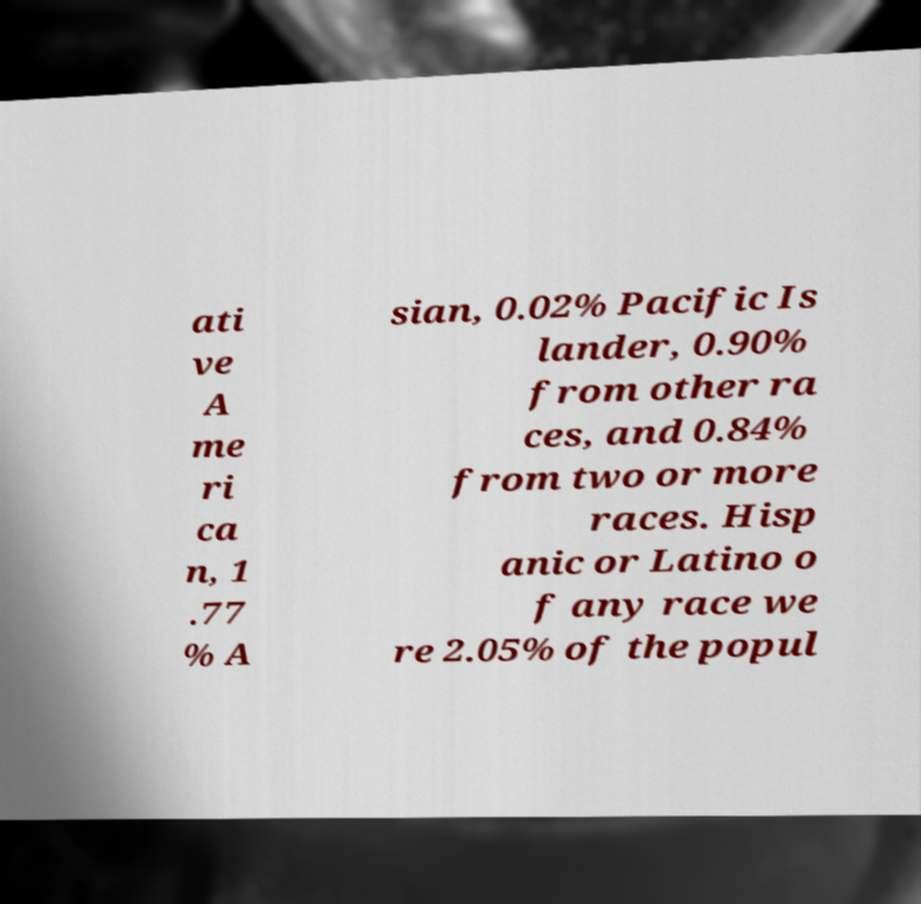What messages or text are displayed in this image? I need them in a readable, typed format. ati ve A me ri ca n, 1 .77 % A sian, 0.02% Pacific Is lander, 0.90% from other ra ces, and 0.84% from two or more races. Hisp anic or Latino o f any race we re 2.05% of the popul 